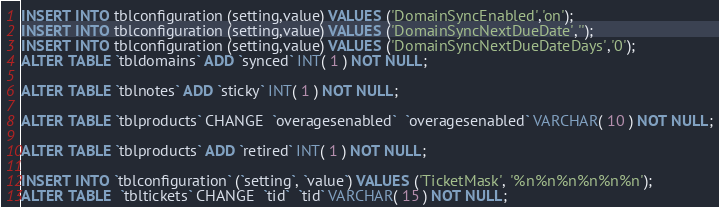<code> <loc_0><loc_0><loc_500><loc_500><_SQL_>INSERT INTO tblconfiguration (setting,value) VALUES ('DomainSyncEnabled','on');
INSERT INTO tblconfiguration (setting,value) VALUES ('DomainSyncNextDueDate','');
INSERT INTO tblconfiguration (setting,value) VALUES ('DomainSyncNextDueDateDays','0');
ALTER TABLE `tbldomains` ADD `synced` INT( 1 ) NOT NULL;

ALTER TABLE `tblnotes` ADD `sticky` INT( 1 ) NOT NULL;

ALTER TABLE `tblproducts` CHANGE  `overagesenabled`  `overagesenabled` VARCHAR( 10 ) NOT NULL;

ALTER TABLE `tblproducts` ADD `retired` INT( 1 ) NOT NULL;

INSERT INTO `tblconfiguration` (`setting`, `value`) VALUES ('TicketMask', '%n%n%n%n%n%n');
ALTER TABLE  `tbltickets` CHANGE  `tid`  `tid` VARCHAR( 15 ) NOT NULL;
</code> 